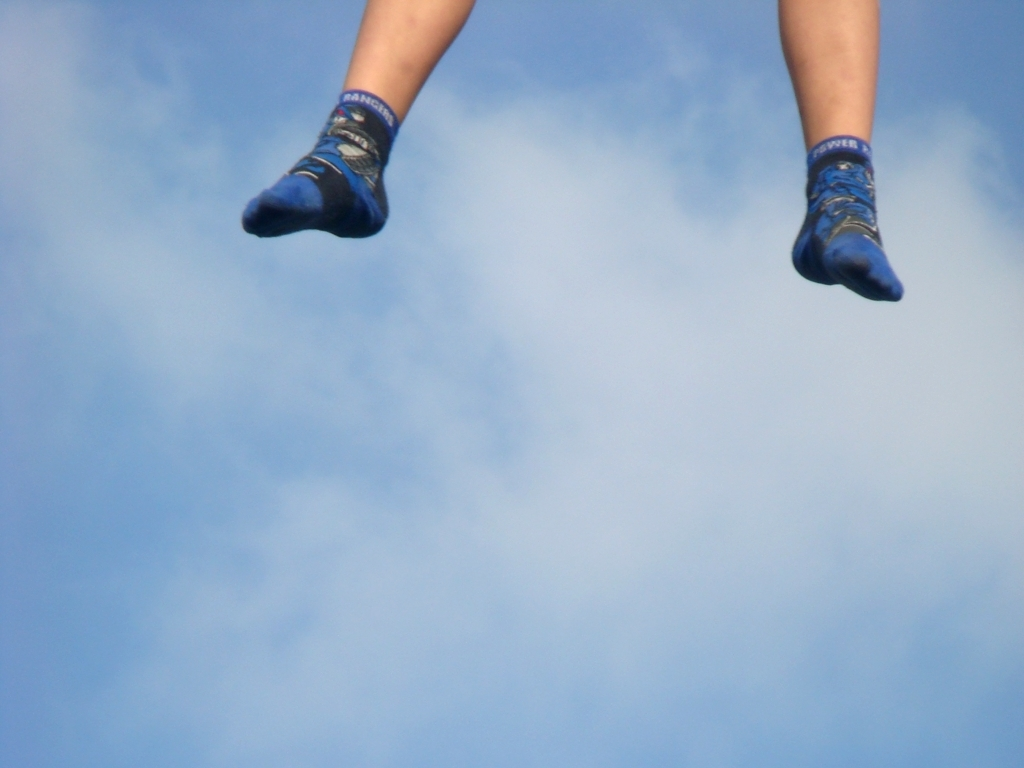Can you deduce any activity the person might be engaging in based on the socks? Given the dynamic nature of the image with the socks in mid-air, it's plausible the person is engaged in a physical activity such as trampoline jumping, skateboarding, or possibly doing a dance move. The sporty design of the socks might also suggest involvement in an athletic event or simply playful leisure. 